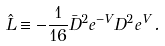<formula> <loc_0><loc_0><loc_500><loc_500>\hat { L } \equiv - \frac { 1 } { 1 6 } \bar { D } ^ { 2 } e ^ { - V } D ^ { 2 } e ^ { V } \, .</formula> 